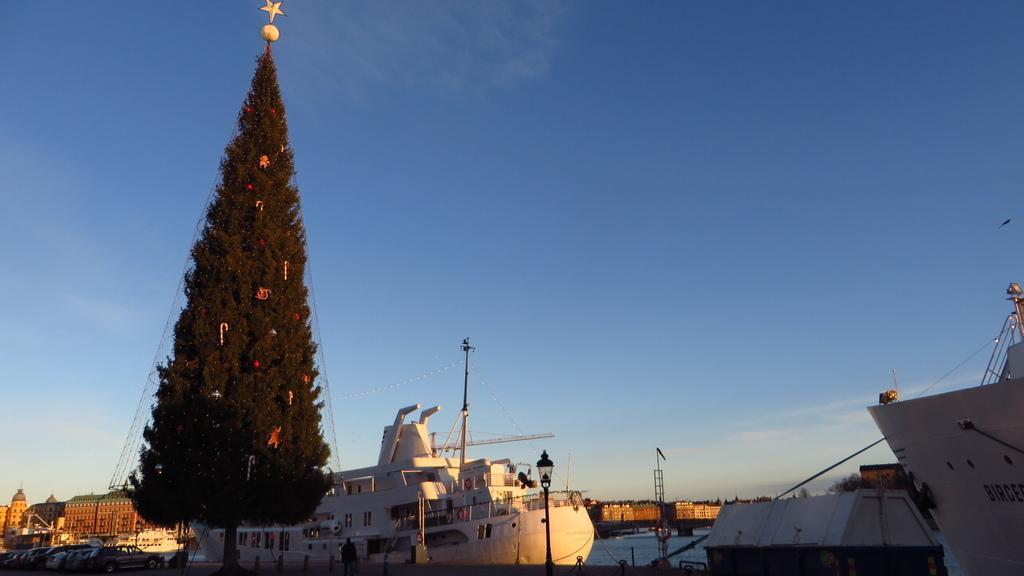Could you give a brief overview of what you see in this image? In this image I can see the ships. On the left side I can see a tree. In the background, I can see the buildings and clouds in the sky. 